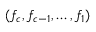<formula> <loc_0><loc_0><loc_500><loc_500>( f _ { c } , f _ { c - 1 } , \dots , f _ { 1 } )</formula> 